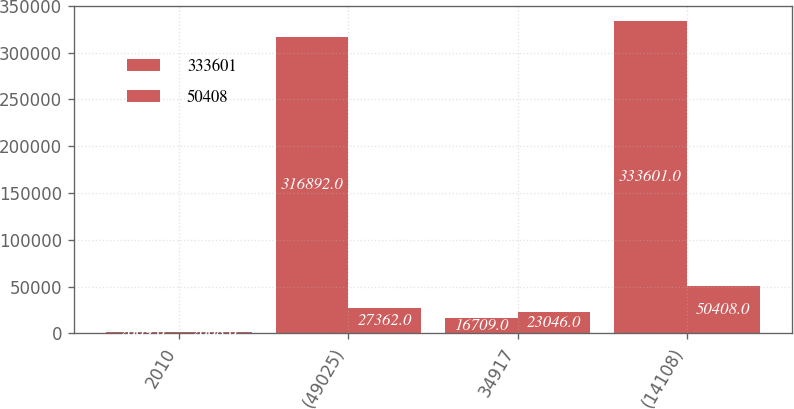Convert chart to OTSL. <chart><loc_0><loc_0><loc_500><loc_500><stacked_bar_chart><ecel><fcel>2010<fcel>(49025)<fcel>34917<fcel>(14108)<nl><fcel>333601<fcel>2009<fcel>316892<fcel>16709<fcel>333601<nl><fcel>50408<fcel>2008<fcel>27362<fcel>23046<fcel>50408<nl></chart> 